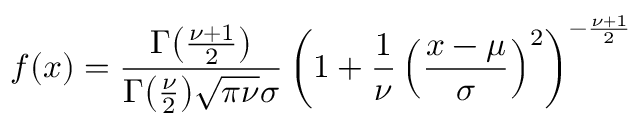Convert formula to latex. <formula><loc_0><loc_0><loc_500><loc_500>f ( x ) = { \frac { \Gamma { \left ( } { \frac { \nu + 1 } { 2 } } { \right ) } } { \Gamma { \left ( } { \frac { \nu } { 2 } } { \right ) } { \sqrt { \pi \nu } } \sigma } } \left ( 1 + { \frac { 1 } { \nu } } \left ( { \frac { x - \mu } { \sigma } } \right ) ^ { 2 } \right ) ^ { - { \frac { \nu + 1 } { 2 } } }</formula> 